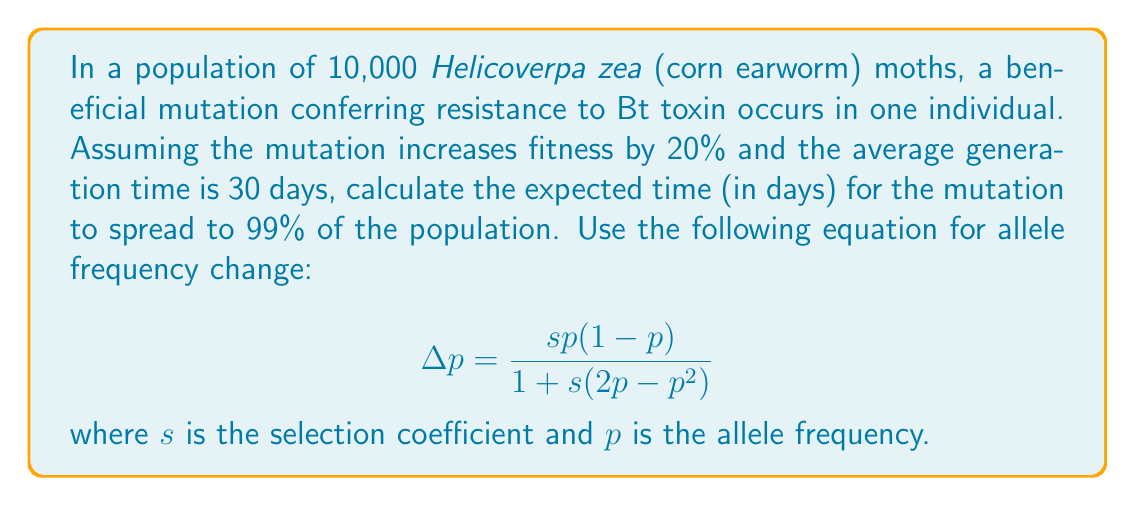Can you answer this question? To solve this problem, we'll follow these steps:

1) Initial frequency: $p_0 = \frac{1}{20000} = 0.00005$ (one copy in 10,000 diploid individuals)

2) Target frequency: $p_f = 0.99$

3) Selection coefficient: $s = 0.2$ (20% fitness increase)

4) We'll use the equation iteratively to calculate the frequency change per generation:

   $$\Delta p = \frac{sp(1-p)}{1+s(2p-p^2)}$$

5) Starting with $p_0$, we'll calculate $p_1 = p_0 + \Delta p$, then use $p_1$ to calculate $p_2$, and so on until we reach $p_f$.

6) We'll count the number of iterations (generations) needed to reach $p_f$.

7) Finally, we'll multiply the number of generations by the generation time (30 days) to get the total time.

Python code for this calculation:

```python
p = 0.00005
s = 0.2
generations = 0

while p < 0.99:
    delta_p = (s * p * (1-p)) / (1 + s * (2*p - p**2))
    p += delta_p
    generations += 1

days = generations * 30
```

This code yields 217 generations, which translates to 6,510 days.
Answer: 6,510 days 